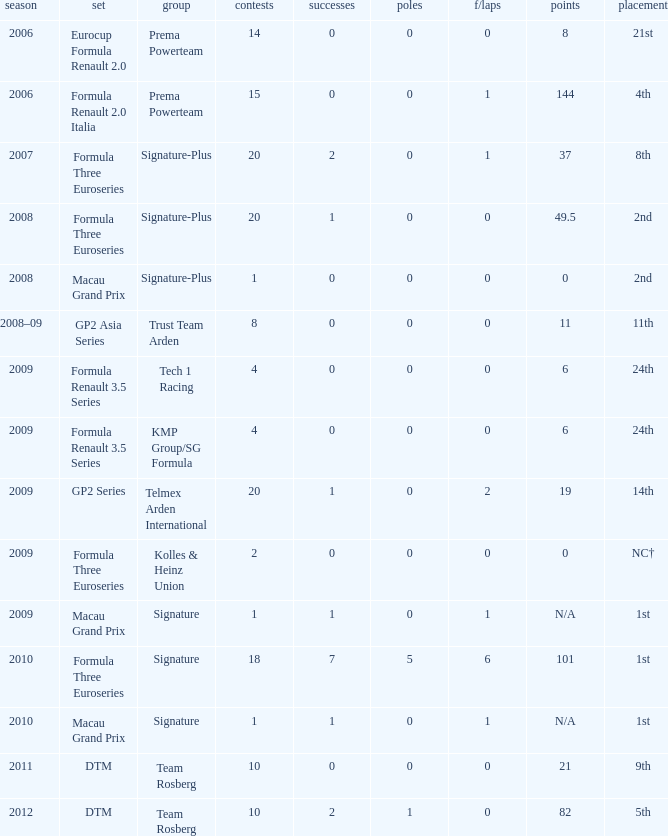Which series has 11 points? GP2 Asia Series. 